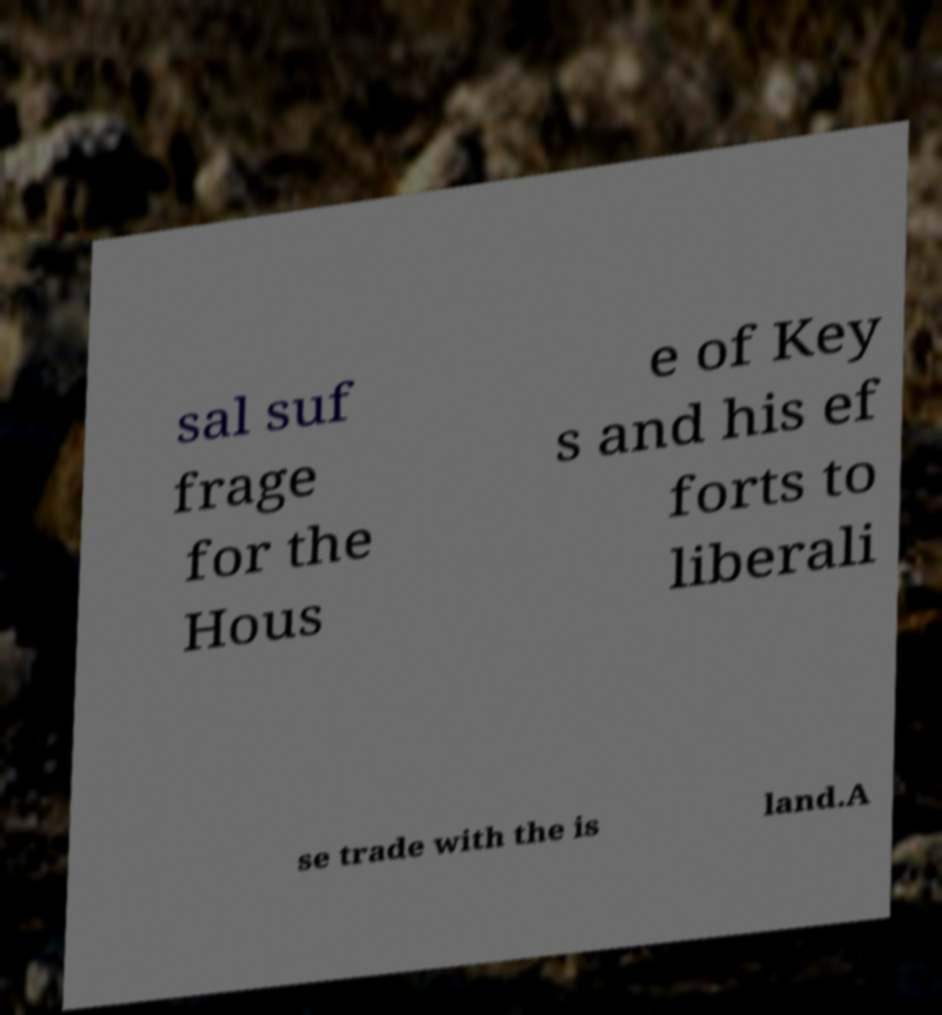Could you assist in decoding the text presented in this image and type it out clearly? sal suf frage for the Hous e of Key s and his ef forts to liberali se trade with the is land.A 